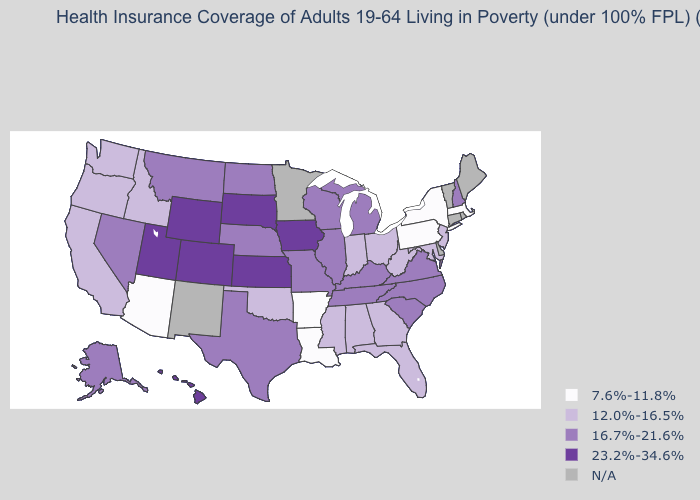What is the value of Missouri?
Short answer required. 16.7%-21.6%. Which states have the highest value in the USA?
Answer briefly. Colorado, Hawaii, Iowa, Kansas, South Dakota, Utah, Wyoming. How many symbols are there in the legend?
Keep it brief. 5. Among the states that border New Mexico , which have the lowest value?
Be succinct. Arizona. Which states have the highest value in the USA?
Be succinct. Colorado, Hawaii, Iowa, Kansas, South Dakota, Utah, Wyoming. Name the states that have a value in the range N/A?
Concise answer only. Connecticut, Delaware, Maine, Minnesota, New Mexico, Rhode Island, Vermont. Does West Virginia have the highest value in the South?
Answer briefly. No. Name the states that have a value in the range 12.0%-16.5%?
Be succinct. Alabama, California, Florida, Georgia, Idaho, Indiana, Maryland, Mississippi, New Jersey, Ohio, Oklahoma, Oregon, Washington, West Virginia. What is the value of Pennsylvania?
Answer briefly. 7.6%-11.8%. Among the states that border Tennessee , which have the highest value?
Quick response, please. Kentucky, Missouri, North Carolina, Virginia. Does Indiana have the lowest value in the MidWest?
Give a very brief answer. Yes. Does Arkansas have the lowest value in the USA?
Give a very brief answer. Yes. 